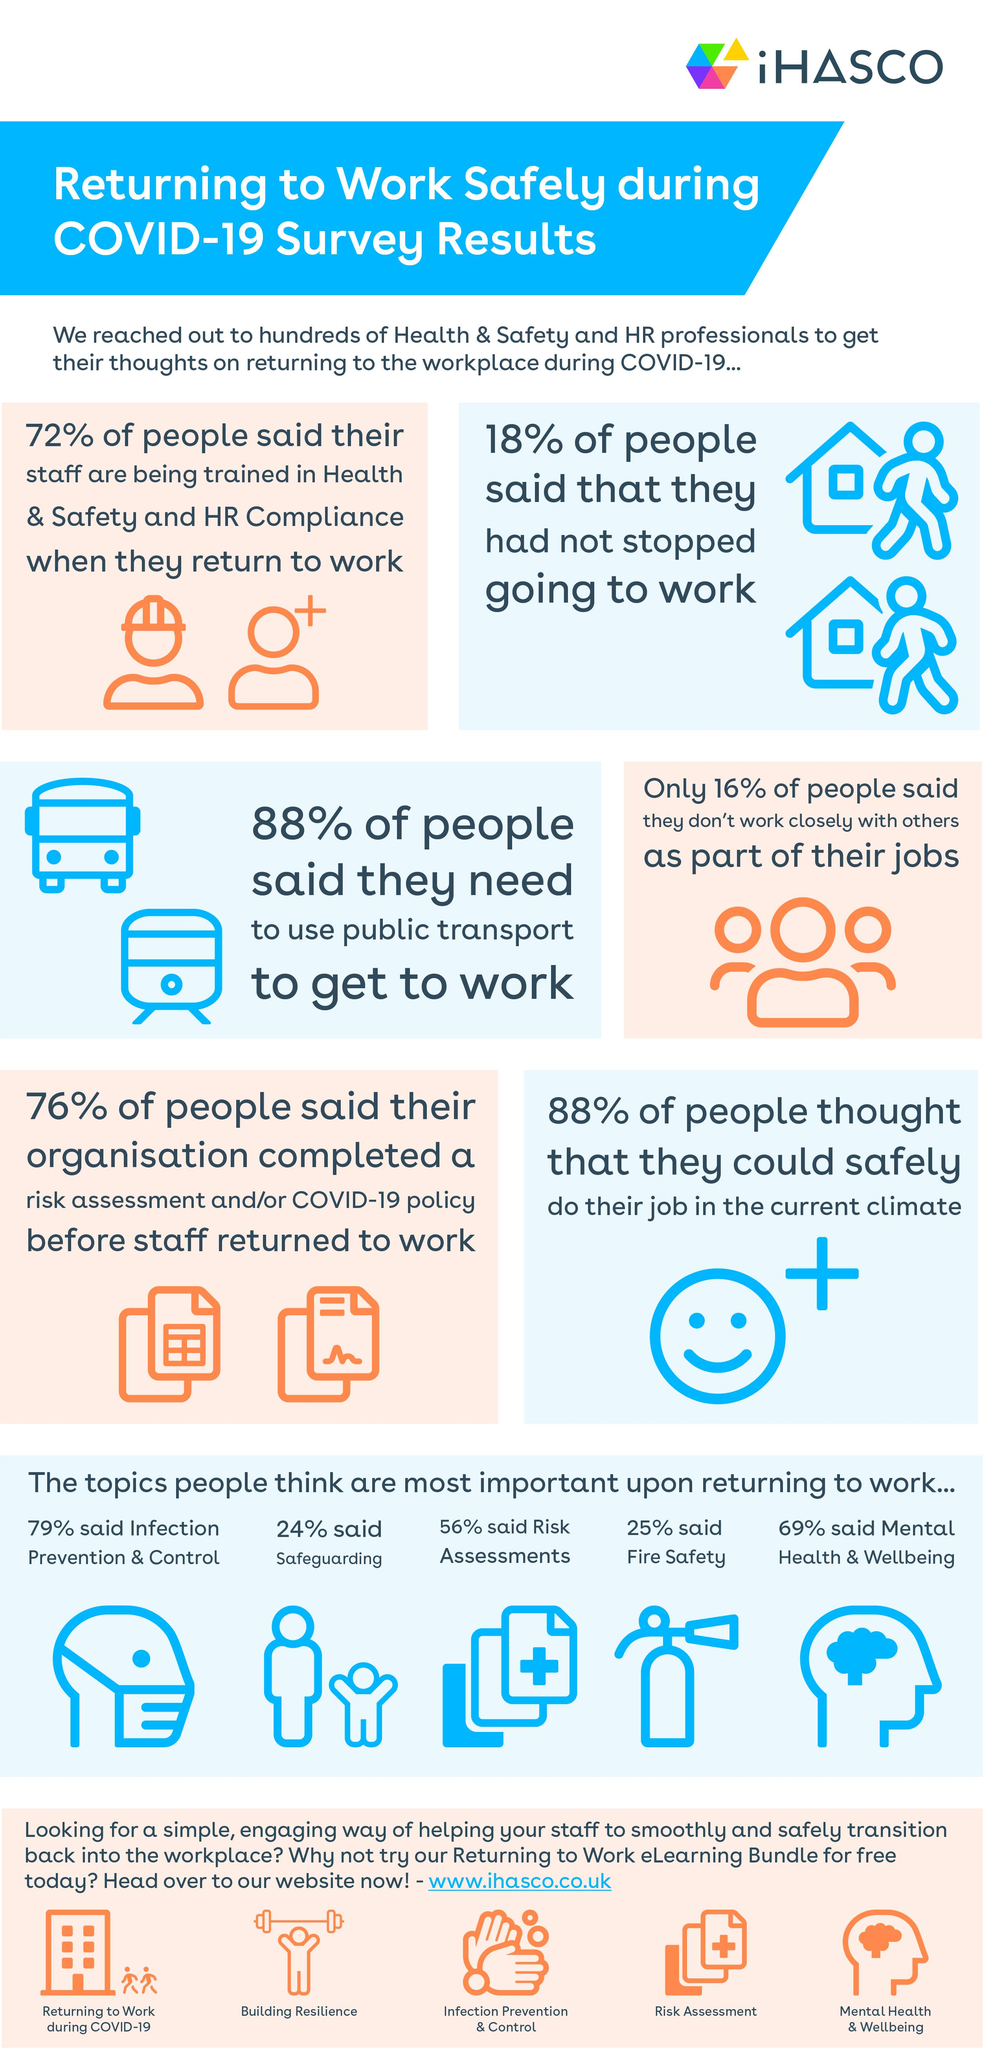Specify some key components in this picture. According to the study, 82% of Health and Safety and HR Professionals have stopped going to work due to stress. Approximately 12% of people do not need to use public transport. Infection prevention and control is the topic that is most important to a majority of people. 